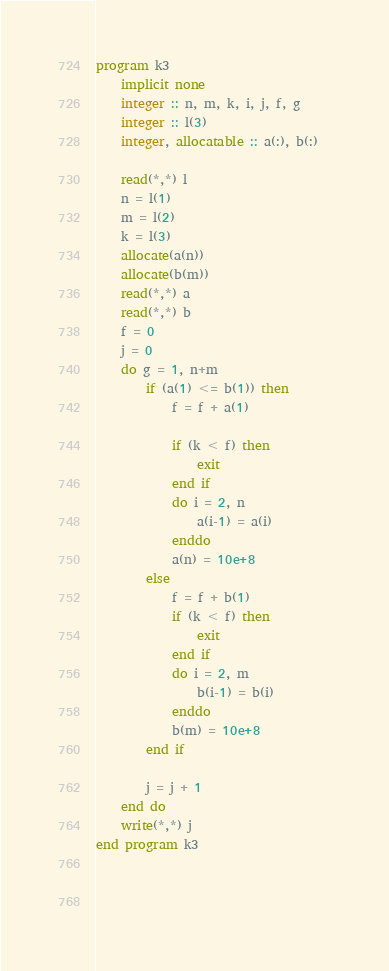<code> <loc_0><loc_0><loc_500><loc_500><_FORTRAN_>program k3
	implicit none
    integer :: n, m, k, i, j, f, g
    integer :: l(3)
    integer, allocatable :: a(:), b(:)
    
    read(*,*) l
    n = l(1)
    m = l(2)
    k = l(3)
    allocate(a(n))
    allocate(b(m))
    read(*,*) a
    read(*,*) b
    f = 0
    j = 0
    do g = 1, n+m
    	if (a(1) <= b(1)) then
        	f = f + a(1)
          
            if (k < f) then
                exit
            end if            
            do i = 2, n
            	a(i-1) = a(i)
            enddo
            a(n) = 10e+8            
        else
         	f = f + b(1)
            if (k < f) then
                exit
            end if 
            do i = 2, m
            	b(i-1) = b(i)
            enddo 
            b(m) = 10e+8
    	end if

		j = j + 1
    end do
   	write(*,*) j
end program k3
    
    
    </code> 